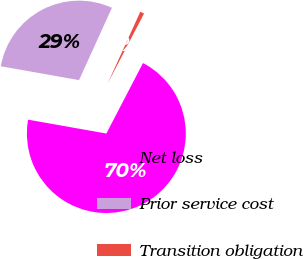Convert chart. <chart><loc_0><loc_0><loc_500><loc_500><pie_chart><fcel>Net loss<fcel>Prior service cost<fcel>Transition obligation<nl><fcel>70.16%<fcel>29.0%<fcel>0.84%<nl></chart> 